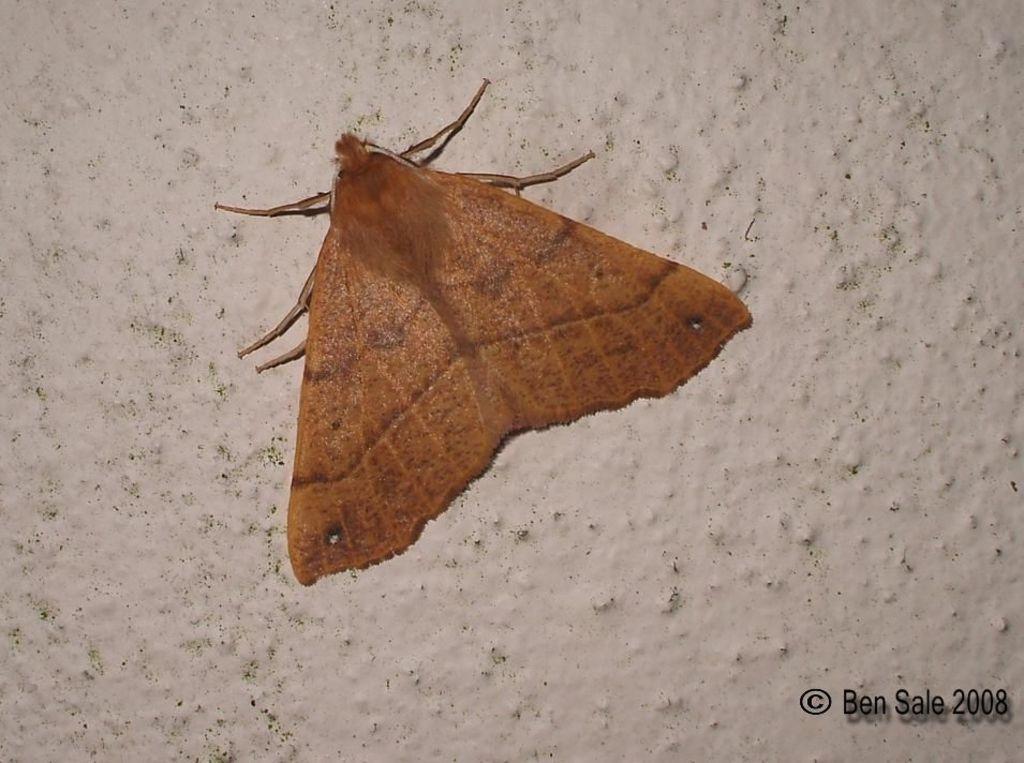Please provide a concise description of this image. In this picture, we see an insect which looks like a butterfly is on the wall. It is in brown color. In the background, we see a wall in white color. 